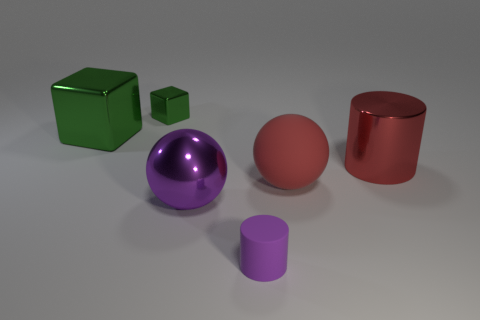There is a sphere that is the same color as the matte cylinder; what is it made of?
Provide a short and direct response. Metal. There is a metal sphere that is the same color as the matte cylinder; what is its size?
Offer a very short reply. Large. Is there a tiny matte thing?
Provide a short and direct response. Yes. What is the size of the thing behind the big metal cube?
Your answer should be very brief. Small. What number of large metal objects are the same color as the large cylinder?
Ensure brevity in your answer.  0. What number of spheres are either purple metal things or gray shiny objects?
Make the answer very short. 1. The object that is in front of the tiny green shiny block and behind the shiny cylinder has what shape?
Provide a short and direct response. Cube. Are there any cubes of the same size as the red shiny cylinder?
Give a very brief answer. Yes. What number of objects are large shiny objects that are right of the large purple ball or large purple shiny objects?
Give a very brief answer. 2. Does the big purple object have the same material as the cube to the left of the tiny green block?
Offer a very short reply. Yes. 